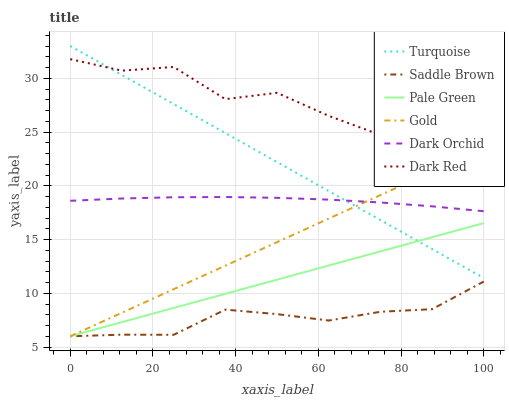Does Saddle Brown have the minimum area under the curve?
Answer yes or no. Yes. Does Dark Red have the maximum area under the curve?
Answer yes or no. Yes. Does Gold have the minimum area under the curve?
Answer yes or no. No. Does Gold have the maximum area under the curve?
Answer yes or no. No. Is Pale Green the smoothest?
Answer yes or no. Yes. Is Dark Red the roughest?
Answer yes or no. Yes. Is Gold the smoothest?
Answer yes or no. No. Is Gold the roughest?
Answer yes or no. No. Does Gold have the lowest value?
Answer yes or no. Yes. Does Dark Red have the lowest value?
Answer yes or no. No. Does Turquoise have the highest value?
Answer yes or no. Yes. Does Gold have the highest value?
Answer yes or no. No. Is Saddle Brown less than Turquoise?
Answer yes or no. Yes. Is Dark Red greater than Pale Green?
Answer yes or no. Yes. Does Pale Green intersect Gold?
Answer yes or no. Yes. Is Pale Green less than Gold?
Answer yes or no. No. Is Pale Green greater than Gold?
Answer yes or no. No. Does Saddle Brown intersect Turquoise?
Answer yes or no. No. 